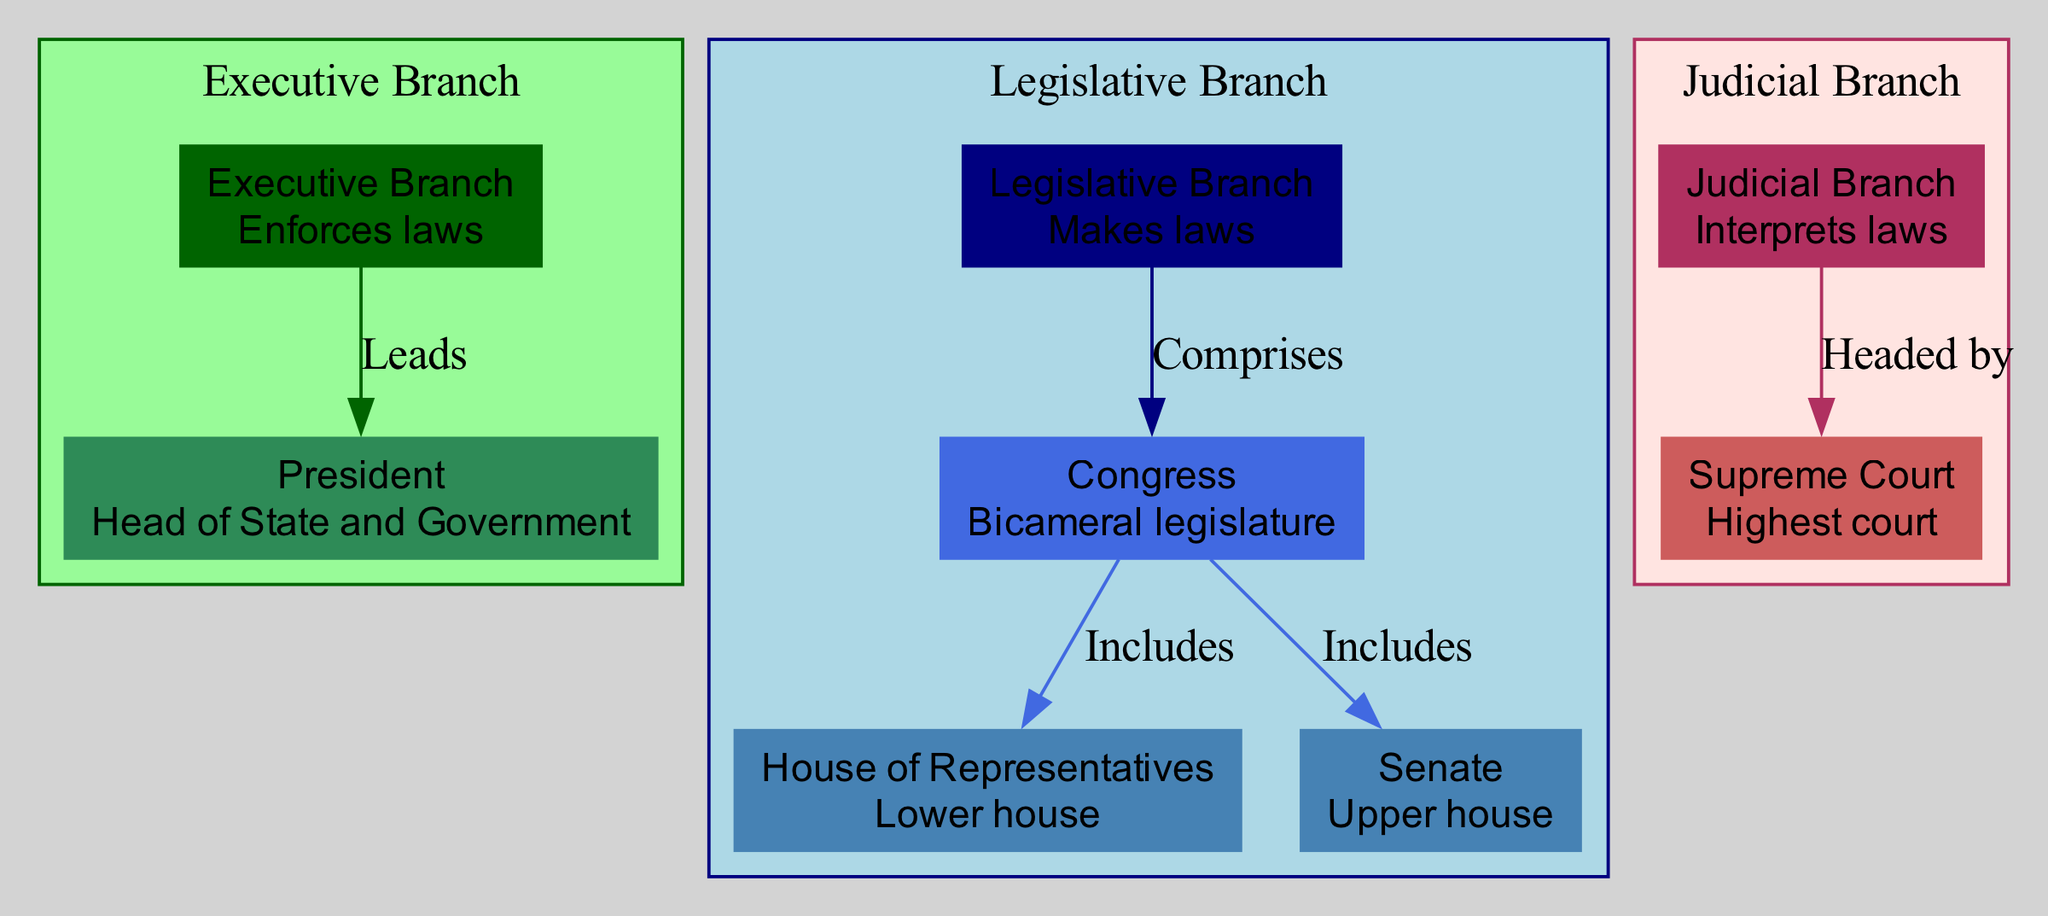What is the main function of the Executive Branch? The diagram shows that the Executive Branch is labeled as "Enforces laws." This is clearly stated in the node description for the Executive Branch, which provides its primary function.
Answer: Enforces laws Who is the head of the Judicial Branch? According to the diagram, the Judicial Branch is headed by the Supreme Court, as indicated in the edge labeled "Headed by." This relationship clearly defines the leadership within the Judicial Branch.
Answer: Supreme Court How many total nodes are there in the diagram? By counting each node labeled in the diagram, we identify the following nodes: Executive Branch, President, Legislative Branch, Congress, House of Representatives, Senate, Judicial Branch, and Supreme Court. This totals to eight nodes.
Answer: 8 What are the two houses that make up Congress? The diagram indicates that Congress includes the House of Representatives and the Senate, as expressed in the edges labeled "Includes." These are the two distinct components of the bicameral legislature.
Answer: House of Representatives, Senate What relationship does the President have with the Executive Branch? The diagram illustrates that the President is part of the Executive Branch and is labeled as "Leads." This signifies the President's leadership role over the entire branch, indicating a supervisory relationship.
Answer: Leads Which branch of government is responsible for making laws? The diagram shows that the Legislative Branch is responsible for making laws, indicated in the node description that states "Makes laws." This directly points to the primary function of this branch.
Answer: Legislative Branch What type of legislature is Congress described as? The diagram clearly describes Congress as a "Bicameral legislature," which is mentioned in the node description for Congress. This term specifies the structural nature of Congress.
Answer: Bicameral legislature How does the Judicial Branch interact with the Supreme Court? The diagram specifies that the Judicial Branch is "Headed by" the Supreme Court, establishing a hierarchical relationship where the Supreme Court leads the Judicial operations.
Answer: Headed by What distinguishes the House of Representatives from the Senate? According to the diagram, both are included in Congress, with the House of Representatives labeled as the "Lower house" and the Senate as the "Upper house," highlighting their respective positions within the legislative structure.
Answer: Lower house, Upper house 